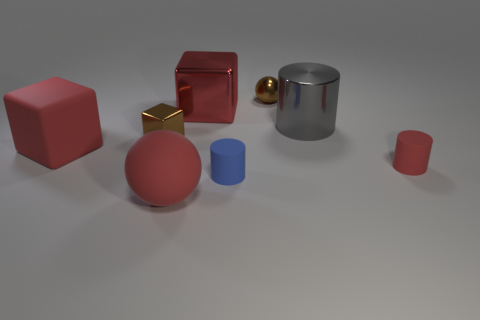Add 1 tiny red things. How many objects exist? 9 Subtract all blocks. How many objects are left? 5 Subtract all small matte things. Subtract all tiny blue rubber objects. How many objects are left? 5 Add 6 large gray things. How many large gray things are left? 7 Add 2 small shiny balls. How many small shiny balls exist? 3 Subtract 0 purple cylinders. How many objects are left? 8 